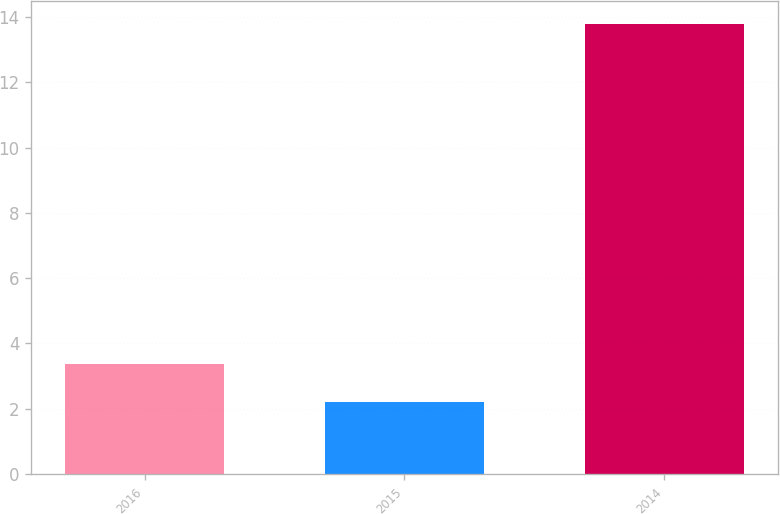<chart> <loc_0><loc_0><loc_500><loc_500><bar_chart><fcel>2016<fcel>2015<fcel>2014<nl><fcel>3.36<fcel>2.2<fcel>13.8<nl></chart> 